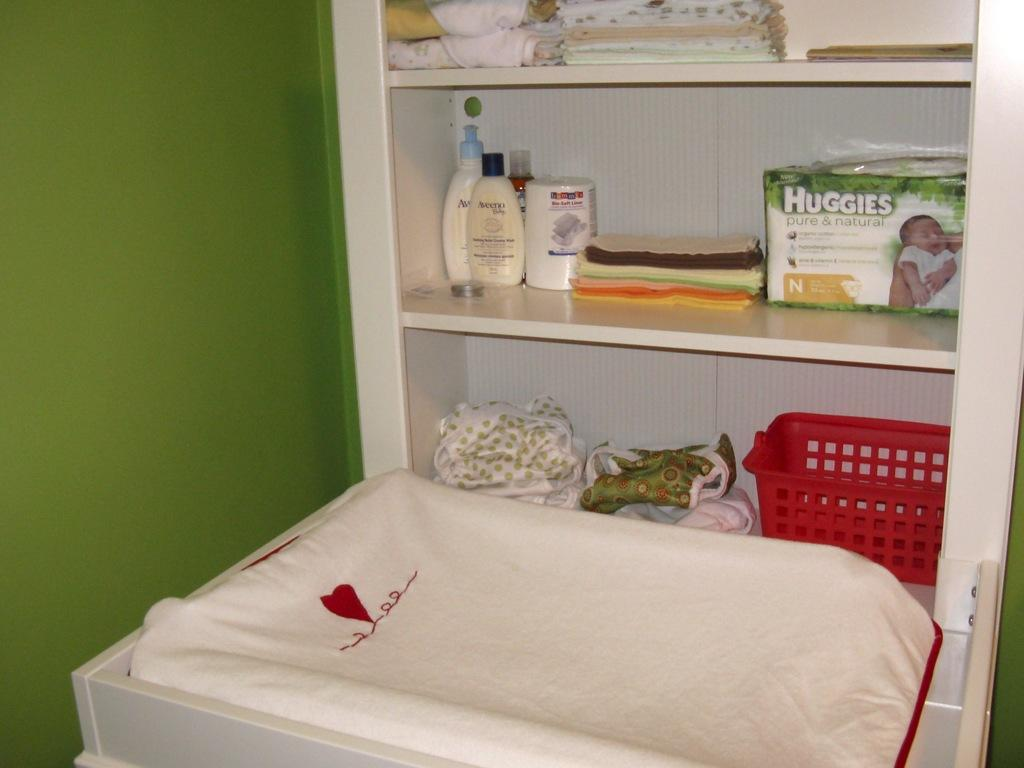<image>
Create a compact narrative representing the image presented. A changing table has shelves behind it with items displayed such as Huggies and Aveeno. 